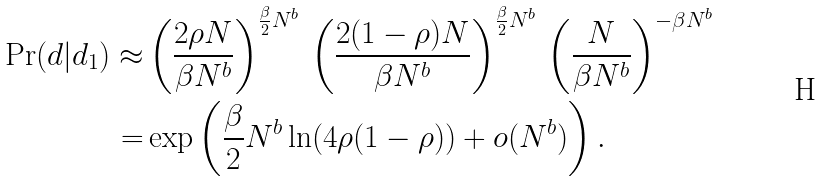<formula> <loc_0><loc_0><loc_500><loc_500>\Pr ( d | d _ { 1 } ) \approx & \left ( \frac { 2 \rho N } { \beta N ^ { b } } \right ) ^ { \frac { \beta } { 2 } N ^ { b } } \, \left ( \frac { 2 ( 1 - \rho ) N } { \beta N ^ { b } } \right ) ^ { \frac { \beta } { 2 } N ^ { b } } \, \left ( \frac { N } { \beta N ^ { b } } \right ) ^ { - \beta N ^ { b } } \\ = & \exp \left ( \frac { \beta } { 2 } N ^ { b } \ln ( 4 \rho ( 1 - \rho ) ) + o ( N ^ { b } ) \right ) .</formula> 